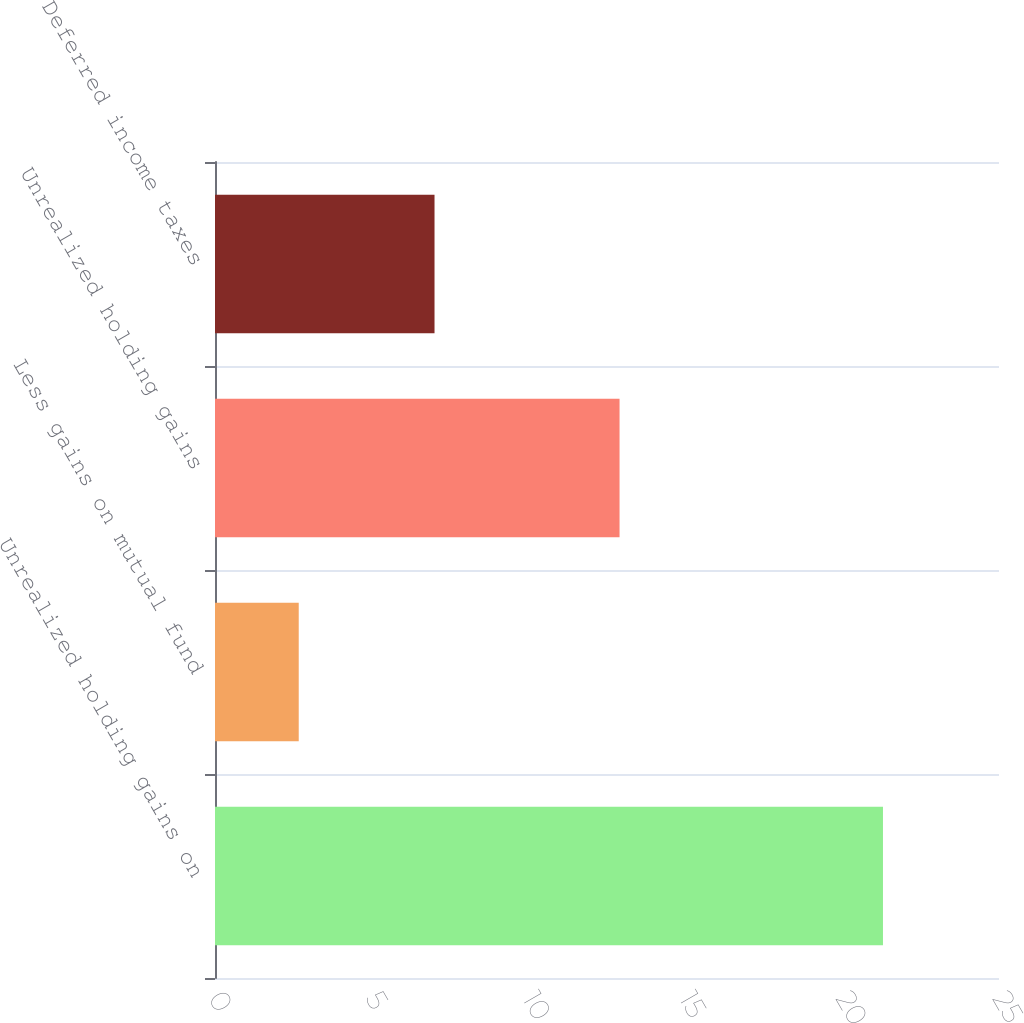Convert chart. <chart><loc_0><loc_0><loc_500><loc_500><bar_chart><fcel>Unrealized holding gains on<fcel>Less gains on mutual fund<fcel>Unrealized holding gains<fcel>Deferred income taxes<nl><fcel>21.3<fcel>2.67<fcel>12.9<fcel>7<nl></chart> 